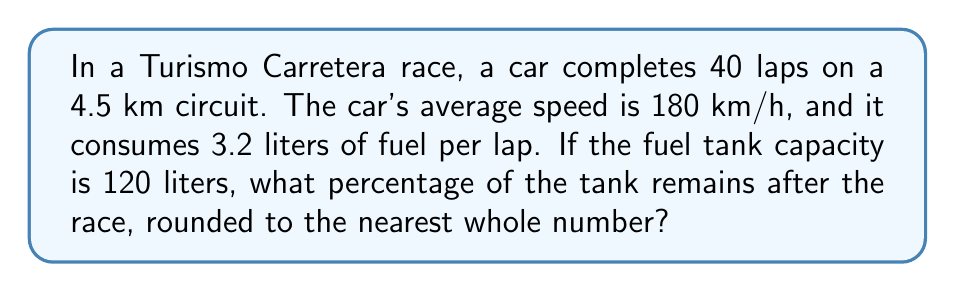Can you answer this question? Let's approach this step-by-step:

1. Calculate the total distance of the race:
   $$ \text{Total distance} = 40 \text{ laps} \times 4.5 \text{ km/lap} = 180 \text{ km} $$

2. Calculate the total time of the race:
   $$ \text{Time} = \frac{\text{Distance}}{\text{Speed}} = \frac{180 \text{ km}}{180 \text{ km/h}} = 1 \text{ hour} $$

3. Calculate the total fuel consumption:
   $$ \text{Fuel consumed} = 40 \text{ laps} \times 3.2 \text{ L/lap} = 128 \text{ L} $$

4. Calculate the fuel remaining:
   $$ \text{Fuel remaining} = 120 \text{ L} - 128 \text{ L} = -8 \text{ L} $$
   This negative value indicates that the car would run out of fuel before finishing the race.

5. Calculate the percentage of fuel used:
   $$ \text{Percentage used} = \frac{128 \text{ L}}{120 \text{ L}} \times 100\% = 106.67\% $$

6. Calculate the percentage remaining:
   $$ \text{Percentage remaining} = 100\% - 106.67\% = -6.67\% $$

7. Round to the nearest whole number:
   $$ \text{Rounded percentage remaining} = -7\% $$

The negative percentage indicates that the car would need 7% more fuel than its tank capacity to complete the race.
Answer: -7% 